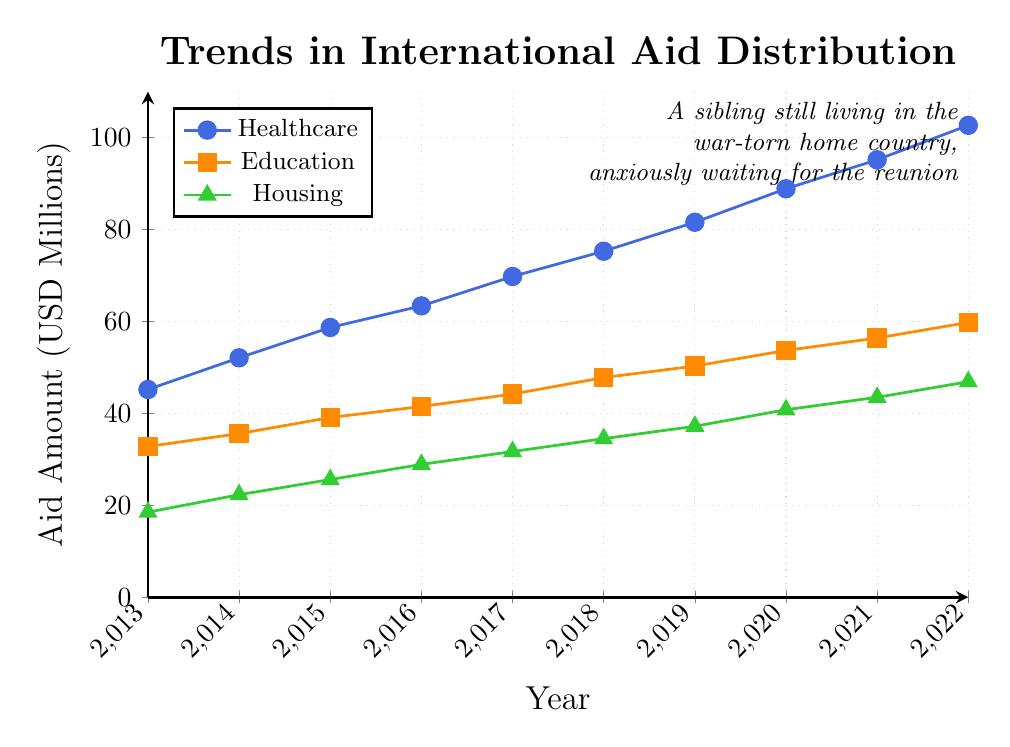How much aid was allocated to healthcare in 2020? Locate the point for healthcare in the year 2020 on the figure. The y-axis value corresponding to this point indicates the aid amount.
Answer: 88.9 million USD Compare the total aid received by the healthcare and education sectors in 2017. Which sector received more, and by how much? Identify the aid amounts for both sectors in 2017: healthcare received 69.8 million and education received 44.2 million. Subtract the smaller value from the larger value.
Answer: Healthcare by 25.6 million USD What was the average annual growth in housing aid from 2013 to 2022? To find the average annual growth, subtract the initial value from the final value, then divide by the number of years minus one: (46.9 - 18.5) / (2022 - 2013).
Answer: Approximately 3.16 million USD per year In what year did the education sector surpass 50 million USD in aid, and what was its exact value? Check the education sector's data points on the figure and identify the first year when the value exceeds 50 million USD.
Answer: 2019, with 50.3 million USD Which sector had the steepest increase in aid between 2013 and 2022? Compare the aid amounts for each sector in 2013 and 2022. Calculate the differences and identify which sector's value increased the most.
Answer: Healthcare (57.5 million USD increase) Plot the trend for housing aid from 2013 to 2022. Identify any years where the increment was higher compared to the previous year. By observing the plotted trend line for housing, note any steeper segments. Identify the pairs of consecutive years with larger increments. For instance, increment from 2017 to 2018 followed by 2018 to 2019, etc.
Answer: From 2014 to 2015 (3.3 million) and from 2019 to 2020 (3.6 million) Which year saw the highest total aid distribution across all sectors? For each year, sum the aid values across all three sectors and compare them.
Answer: 2022 (209.4 million USD total) How does the growth trajectory of healthcare aid compare to that of education aid between 2015 and 2020? Identify the aid values for healthcare and education in 2015 and 2020, then calculate the total increases for both sectors over these years. Compare the resulting growths.
Answer: Healthcare increased by 30.2 million USD; Education increased by 14.6 million USD Was there any year where the percentage increase in housing aid was the highest from the previous year? Calculate the year-on-year percentage change for housing aid: (value in current year - value in previous year) / value in previous year * 100%. Compare these percentages to identify the year with the highest increment.
Answer: From 2013 to 2014 (20.54% increase) What year did healthcare aid reach approximately 70 million USD? Locate the point where the healthcare aid value on the y-axis is around 70 million and identify the corresponding year.
Answer: 2017 